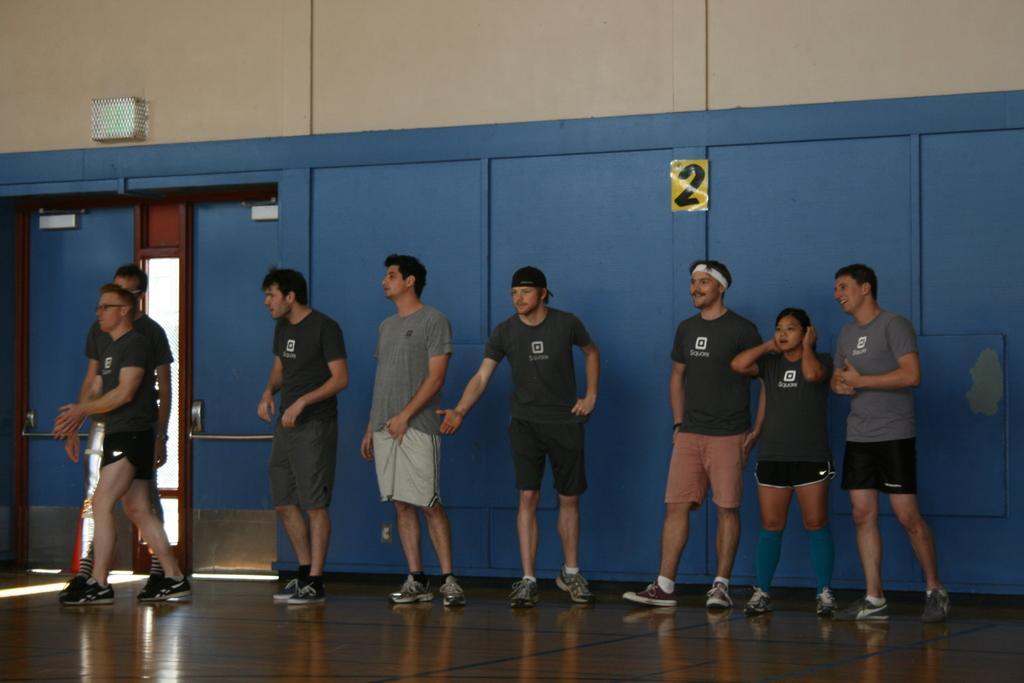Describe this image in one or two sentences. In this picture there is a man who is wearing a black dress, beside him there is a man who is wearing grey t-shirt, short and shoe. On the right we can see the group of person standing on the pitch. On the left there are two persons were standing near to the door. In the top left corner there is a light. 